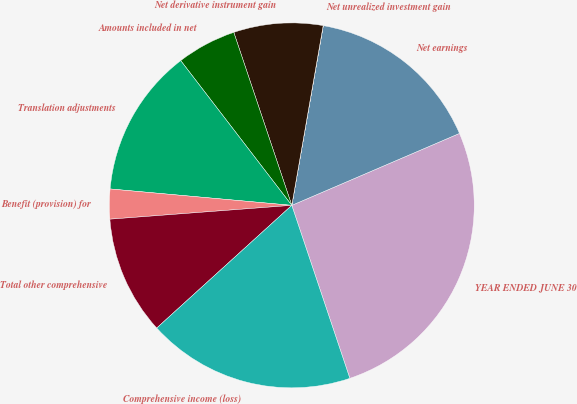<chart> <loc_0><loc_0><loc_500><loc_500><pie_chart><fcel>YEAR ENDED JUNE 30<fcel>Net earnings<fcel>Net unrealized investment gain<fcel>Net derivative instrument gain<fcel>Amounts included in net<fcel>Translation adjustments<fcel>Benefit (provision) for<fcel>Total other comprehensive<fcel>Comprehensive income (loss)<nl><fcel>26.3%<fcel>15.79%<fcel>0.01%<fcel>7.9%<fcel>5.27%<fcel>13.15%<fcel>2.64%<fcel>10.53%<fcel>18.42%<nl></chart> 